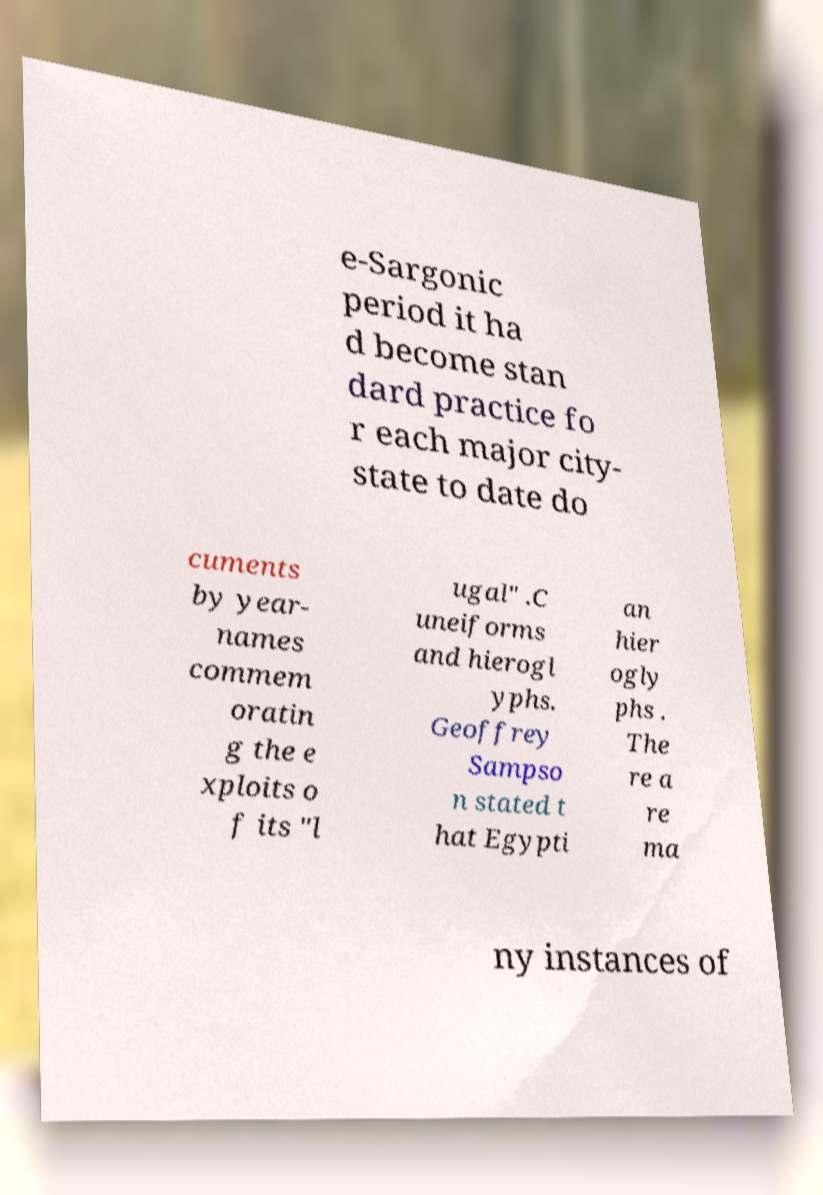Please identify and transcribe the text found in this image. e-Sargonic period it ha d become stan dard practice fo r each major city- state to date do cuments by year- names commem oratin g the e xploits o f its "l ugal" .C uneiforms and hierogl yphs. Geoffrey Sampso n stated t hat Egypti an hier ogly phs . The re a re ma ny instances of 